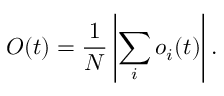<formula> <loc_0><loc_0><loc_500><loc_500>O ( t ) = \frac { 1 } { N } \left | \sum _ { i } o _ { i } ( t ) \right | .</formula> 